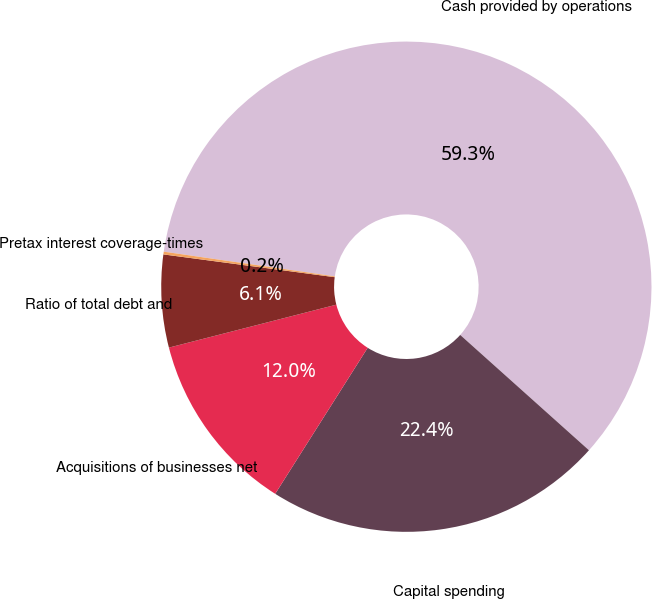Convert chart to OTSL. <chart><loc_0><loc_0><loc_500><loc_500><pie_chart><fcel>Cash provided by operations<fcel>Capital spending<fcel>Acquisitions of businesses net<fcel>Ratio of total debt and<fcel>Pretax interest coverage-times<nl><fcel>59.34%<fcel>22.36%<fcel>12.02%<fcel>6.1%<fcel>0.18%<nl></chart> 